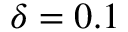Convert formula to latex. <formula><loc_0><loc_0><loc_500><loc_500>\delta = 0 . 1</formula> 